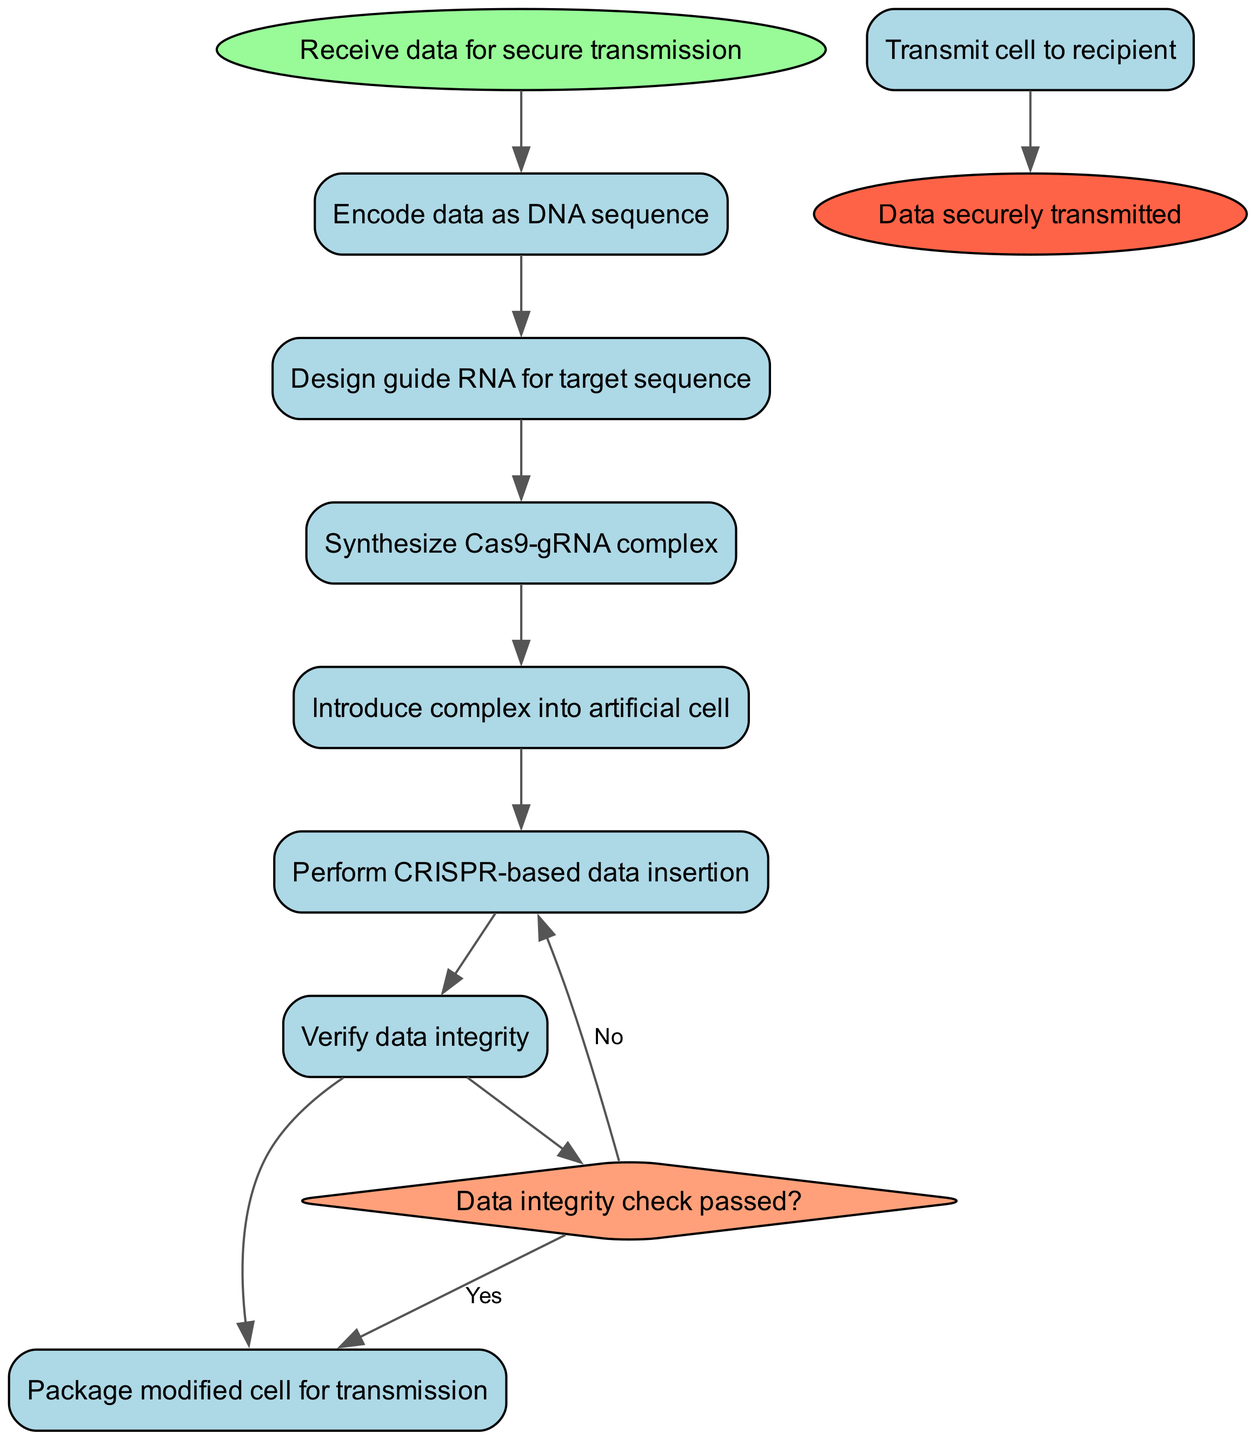What is the starting point of the diagram? The starting point, designated as 'start', is labeled 'Receive data for secure transmission'. This is the first node where the workflow begins.
Answer: Receive data for secure transmission How many activities are there in the workflow? There are eight activities listed in the workflow, which can be counted directly from the 'activities' section of the diagram data.
Answer: Eight What is the final outcome of the diagram? The final outcome is designated as the 'end' node, labeled 'Data securely transmitted'. This indicates the conclusion of the process.
Answer: Data securely transmitted What happens if the data integrity check does not pass? If the data integrity check does not pass, the next action indicated is 'Perform CRISPR-based data insertion', as shown in the decision branching of the diagram.
Answer: Perform CRISPR-based data insertion Which activity comes immediately after designing guide RNA? After 'Design guide RNA for target sequence', the next activity is 'Synthesize Cas9-gRNA complex', which is sequentially connected in the diagram.
Answer: Synthesize Cas9-gRNA complex Which shape represents the decision point in the diagram? The decision point is represented by a diamond shape, which distinguishes it from the rectangular shapes used for activities. This shape usually indicates a branching condition in activity diagrams.
Answer: Diamond In the workflow, what is verified before packaging the modified cell? Before packaging the modified cell, the workflow verifies the 'Data integrity', ensuring that the transmitted information is accurate.
Answer: Data integrity How is the synthesized complex introduced into the workflow? The synthesized Cas9-gRNA complex is introduced into the workflow during the activity 'Introduce complex into artificial cell', which follows the synthesis step.
Answer: Introduce complex into artificial cell 